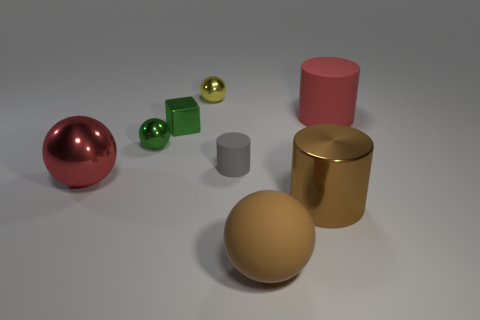Subtract all tiny yellow metallic spheres. How many spheres are left? 3 Add 2 small gray cylinders. How many objects exist? 10 Subtract all gray cylinders. How many cylinders are left? 2 Subtract all red balls. Subtract all gray cylinders. How many balls are left? 3 Subtract all cubes. How many objects are left? 7 Subtract 1 cubes. How many cubes are left? 0 Subtract all cyan cylinders. How many brown spheres are left? 1 Subtract all small green cubes. Subtract all brown balls. How many objects are left? 6 Add 7 small balls. How many small balls are left? 9 Add 6 cyan shiny balls. How many cyan shiny balls exist? 6 